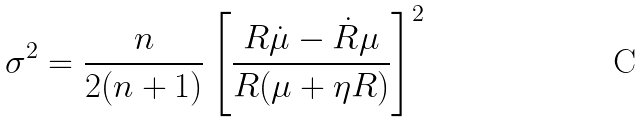Convert formula to latex. <formula><loc_0><loc_0><loc_500><loc_500>\sigma ^ { 2 } = \frac { n } { 2 ( n + 1 ) } \left [ \frac { R \dot { \mu } - \dot { R } \mu } { R ( \mu + \eta R ) } \right ] ^ { 2 }</formula> 